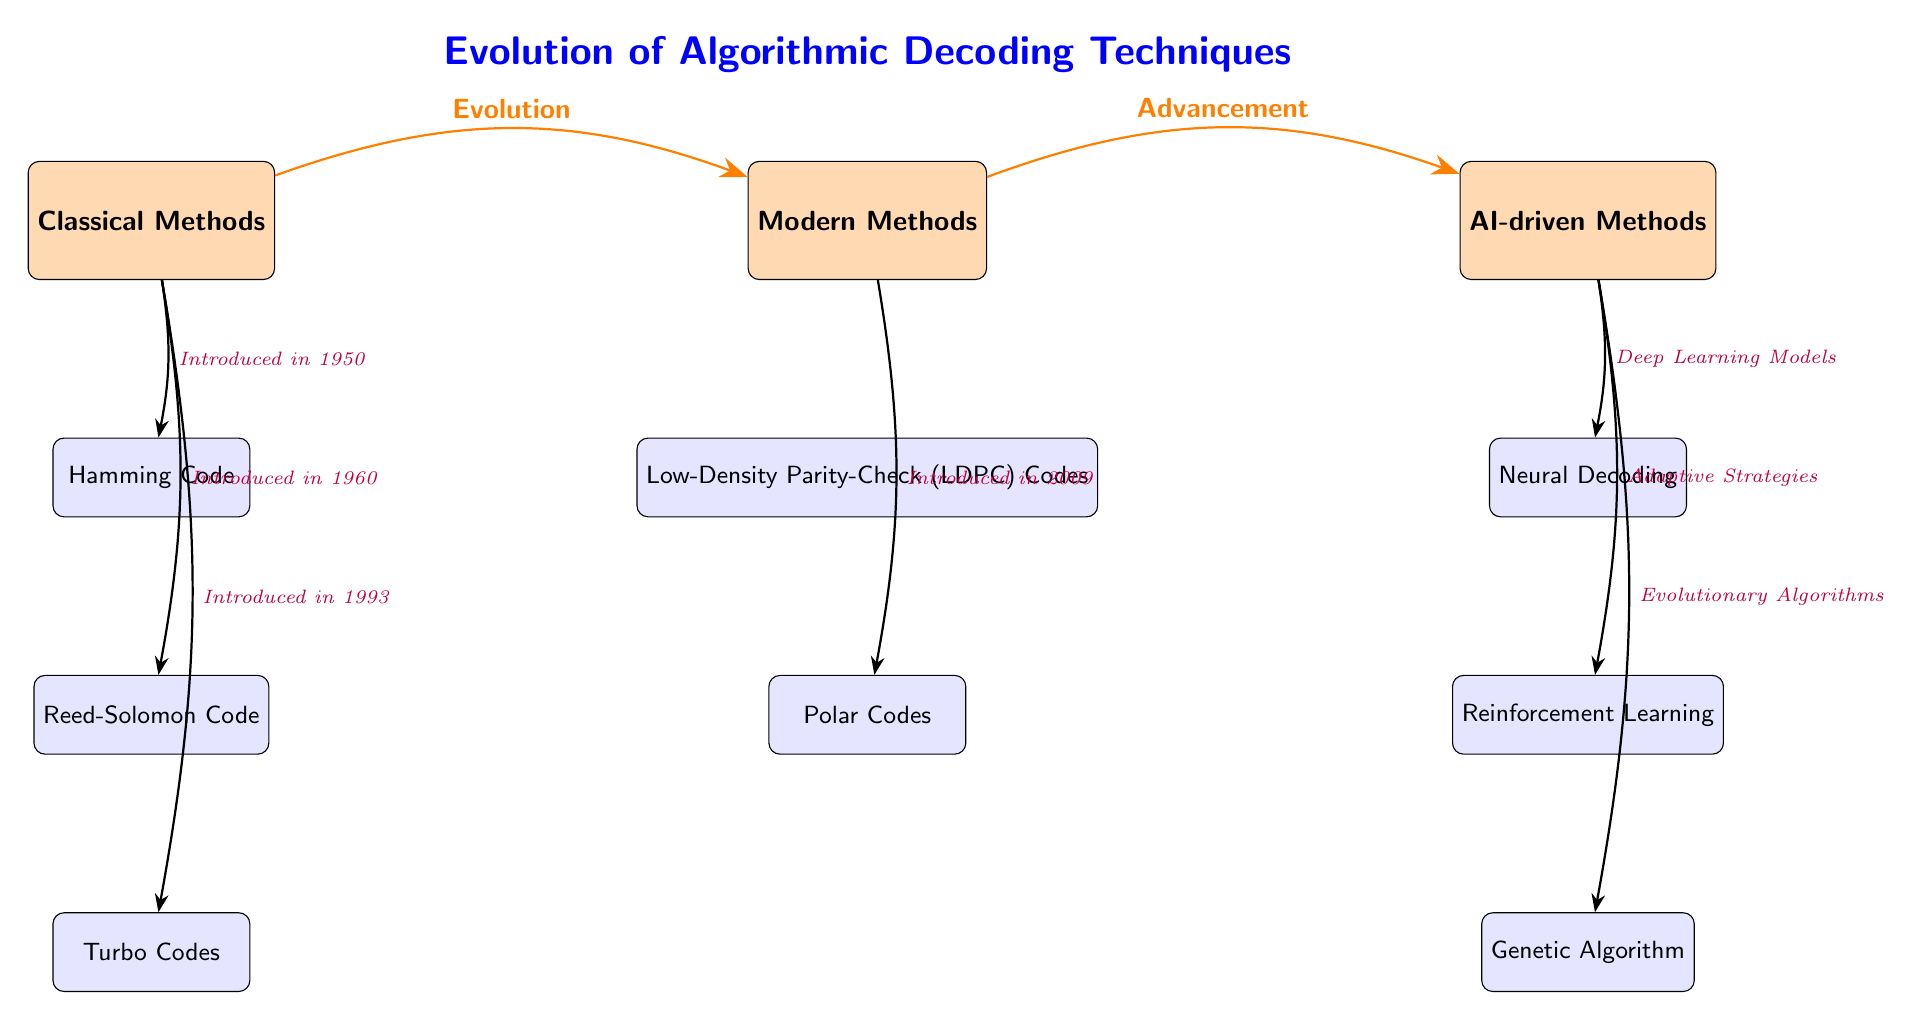What are the three main categories of decoding methods depicted in the diagram? The diagram lists three categories: Classical Methods, Modern Methods, and AI-driven Methods, as indicated at the top of the diagram.
Answer: Classical Methods, Modern Methods, AI-driven Methods Which coding technique was introduced in 1960? The diagram shows that Reed-Solomon Code is connected to the Classical Methods category with an introduction date of 1960, as indicated by the arrow and label.
Answer: Reed-Solomon Code How many methods are under the AI-driven Methods category? The AI-driven Methods category in the diagram lists three techniques: Neural Decoding, Reinforcement Learning, and Genetic Algorithm. Counting these gives a total of three methods.
Answer: 3 What method is directly connected to the AI-driven category with "Deep Learning Models"? The diagram shows that Neural Decoding has an arrow connecting it to the AI-driven Methods category labeled "Deep Learning Models". Thus, Neural Decoding is the method referred to.
Answer: Neural Decoding Based on the diagram, which method represents the evolution from Modern Methods to AI-driven Methods? The arrow indicates the pathway from Modern Methods to AI-driven Methods and shows "Advancement" as its label. The method introduced as a result of this progression is Neural Decoding, which is the first method listed under AI-driven Methods.
Answer: Neural Decoding What is the introduction year of Turbo Codes? The diagram explicitly indicates that Turbo Codes were introduced in 1993, as shown by the arrow connecting it to the Classical Methods category with the corresponding label.
Answer: 1993 Identify the method related to additional strategies under AI-driven Methods. The diagram connects Reinforcement Learning under AI-driven Methods with the label "Adaptive Strategies". This signifies that Reinforcement Learning is the method that relates to additional strategies in this context.
Answer: Reinforcement Learning How many methods are listed under Classical Methods? Under Classical Methods, there are three coding techniques: Hamming Code, Reed-Solomon Code, and Turbo Codes. A simple count of methods provides the answer.
Answer: 3 